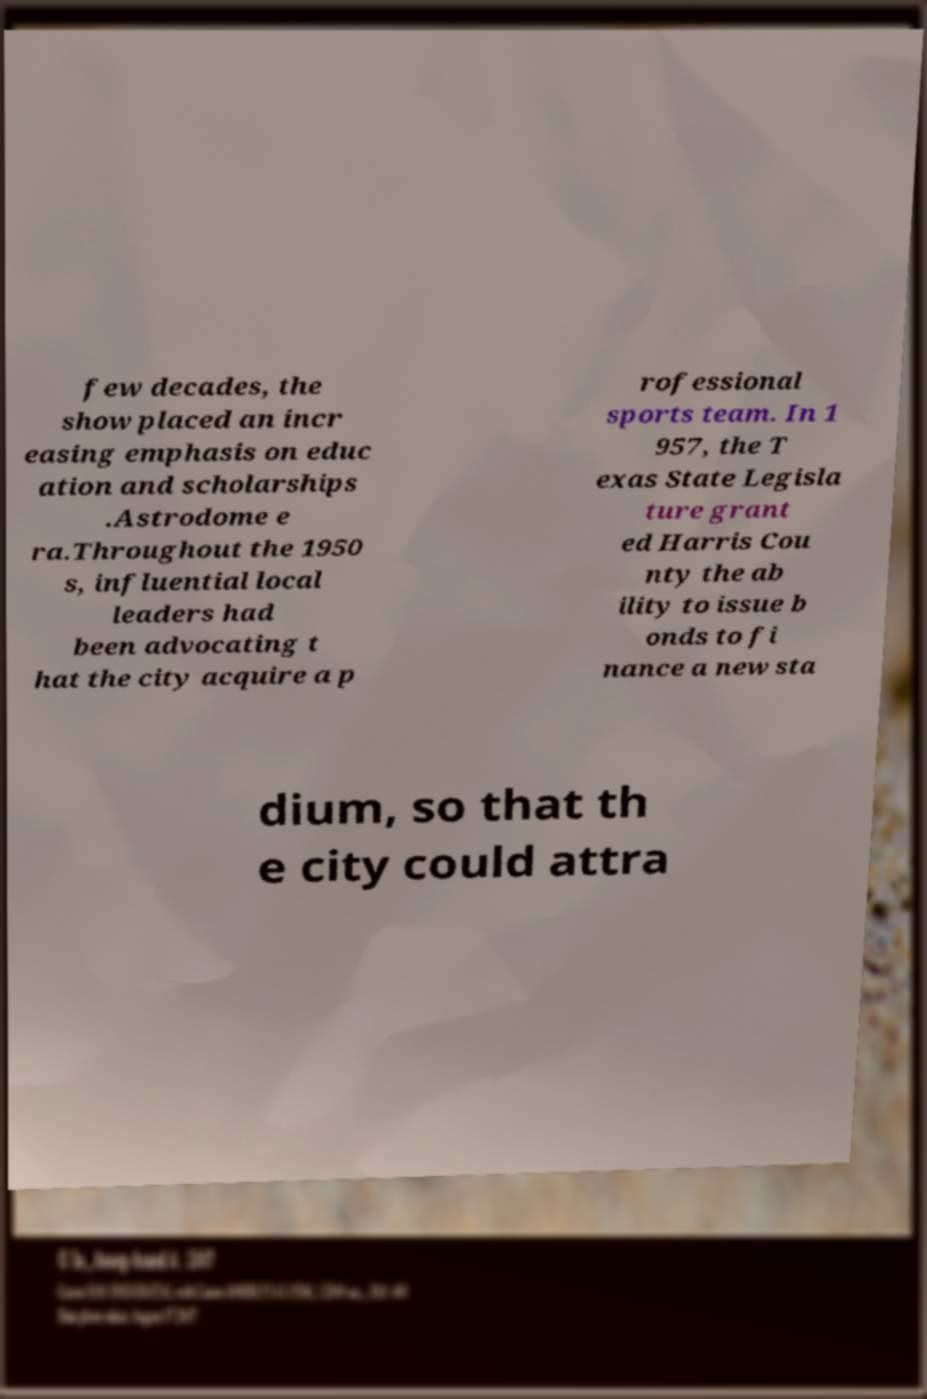I need the written content from this picture converted into text. Can you do that? few decades, the show placed an incr easing emphasis on educ ation and scholarships .Astrodome e ra.Throughout the 1950 s, influential local leaders had been advocating t hat the city acquire a p rofessional sports team. In 1 957, the T exas State Legisla ture grant ed Harris Cou nty the ab ility to issue b onds to fi nance a new sta dium, so that th e city could attra 